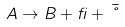Convert formula to latex. <formula><loc_0><loc_0><loc_500><loc_500>A \rightarrow B + \beta + \bar { \nu }</formula> 